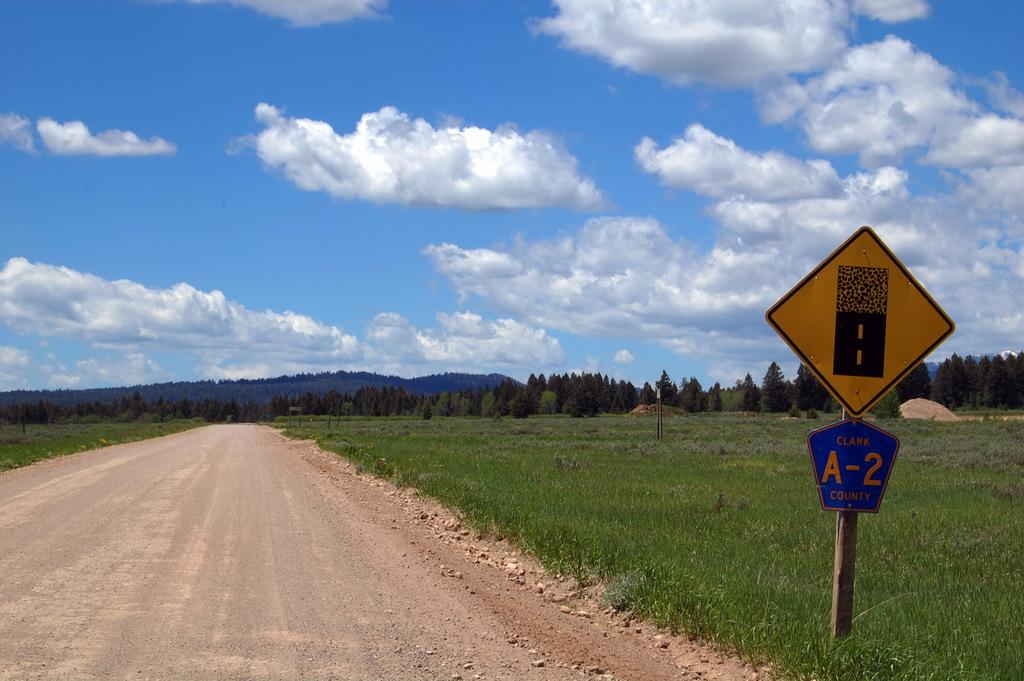<image>
Relay a brief, clear account of the picture shown. Blue and yellow sign which says A-2 on it. 